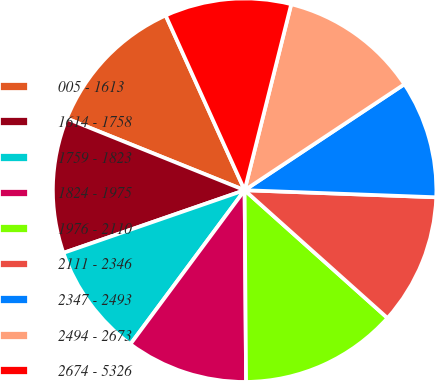Convert chart to OTSL. <chart><loc_0><loc_0><loc_500><loc_500><pie_chart><fcel>005 - 1613<fcel>1614 - 1758<fcel>1759 - 1823<fcel>1824 - 1975<fcel>1976 - 2110<fcel>2111 - 2346<fcel>2347 - 2493<fcel>2494 - 2673<fcel>2674 - 5326<nl><fcel>12.15%<fcel>11.4%<fcel>9.54%<fcel>10.28%<fcel>13.26%<fcel>11.03%<fcel>9.91%<fcel>11.77%<fcel>10.66%<nl></chart> 